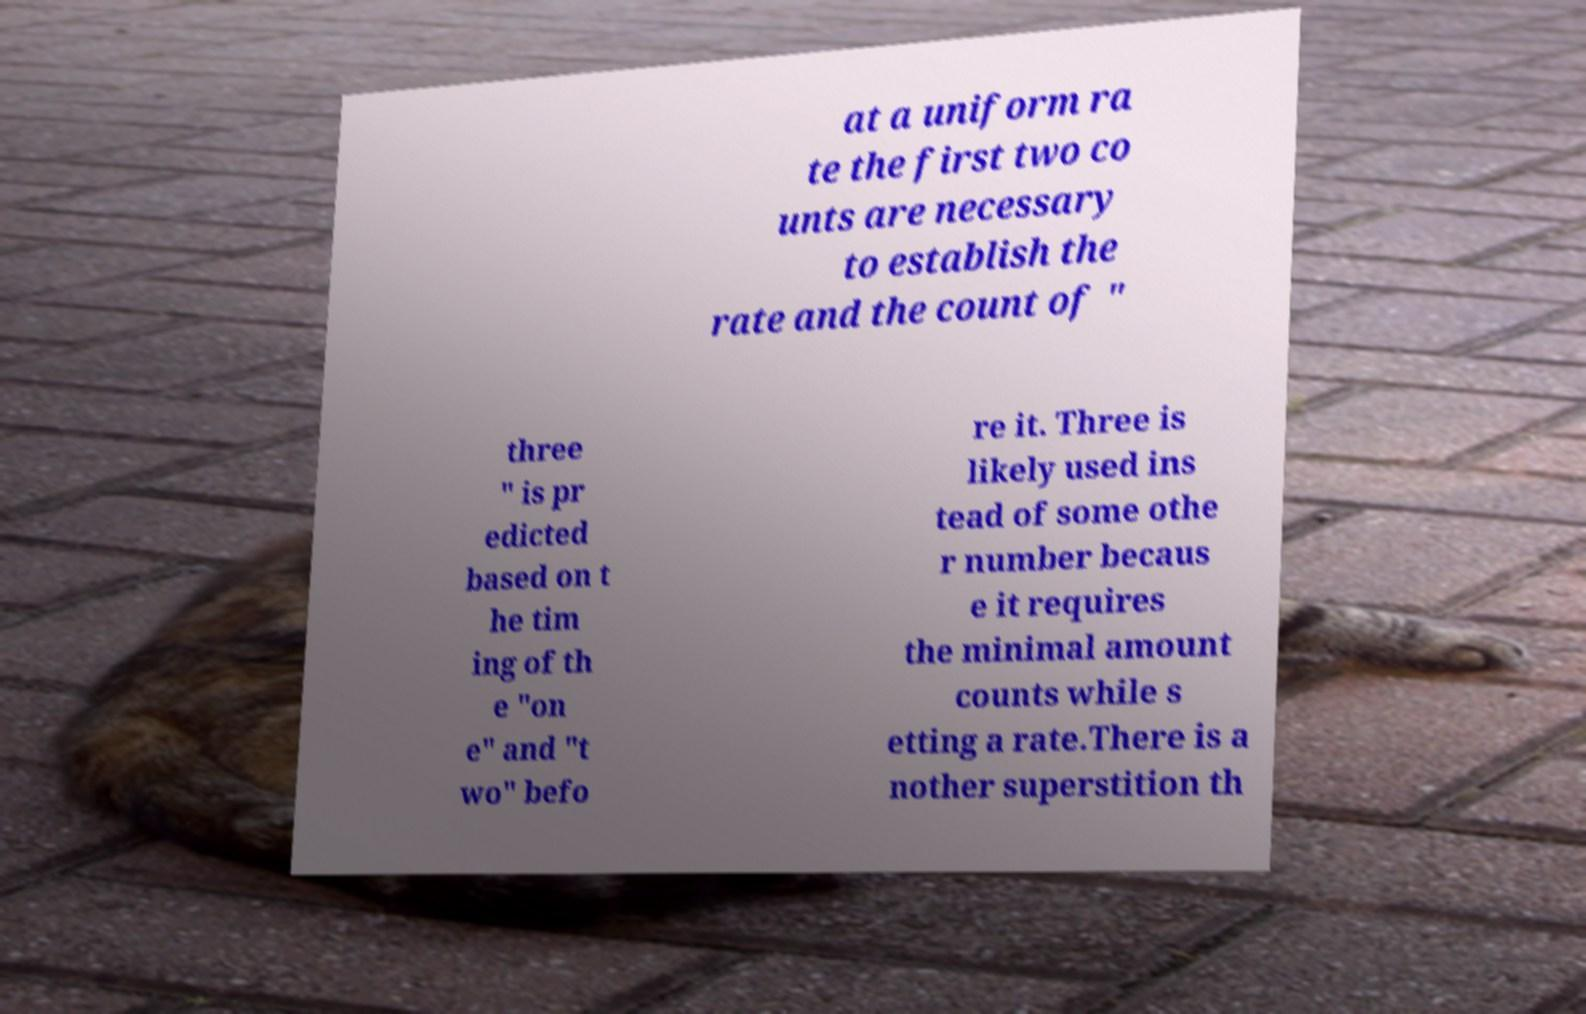Could you extract and type out the text from this image? at a uniform ra te the first two co unts are necessary to establish the rate and the count of " three " is pr edicted based on t he tim ing of th e "on e" and "t wo" befo re it. Three is likely used ins tead of some othe r number becaus e it requires the minimal amount counts while s etting a rate.There is a nother superstition th 